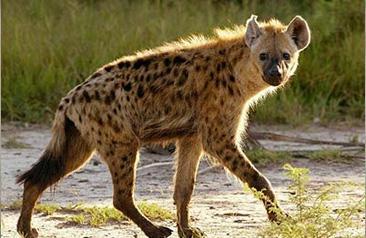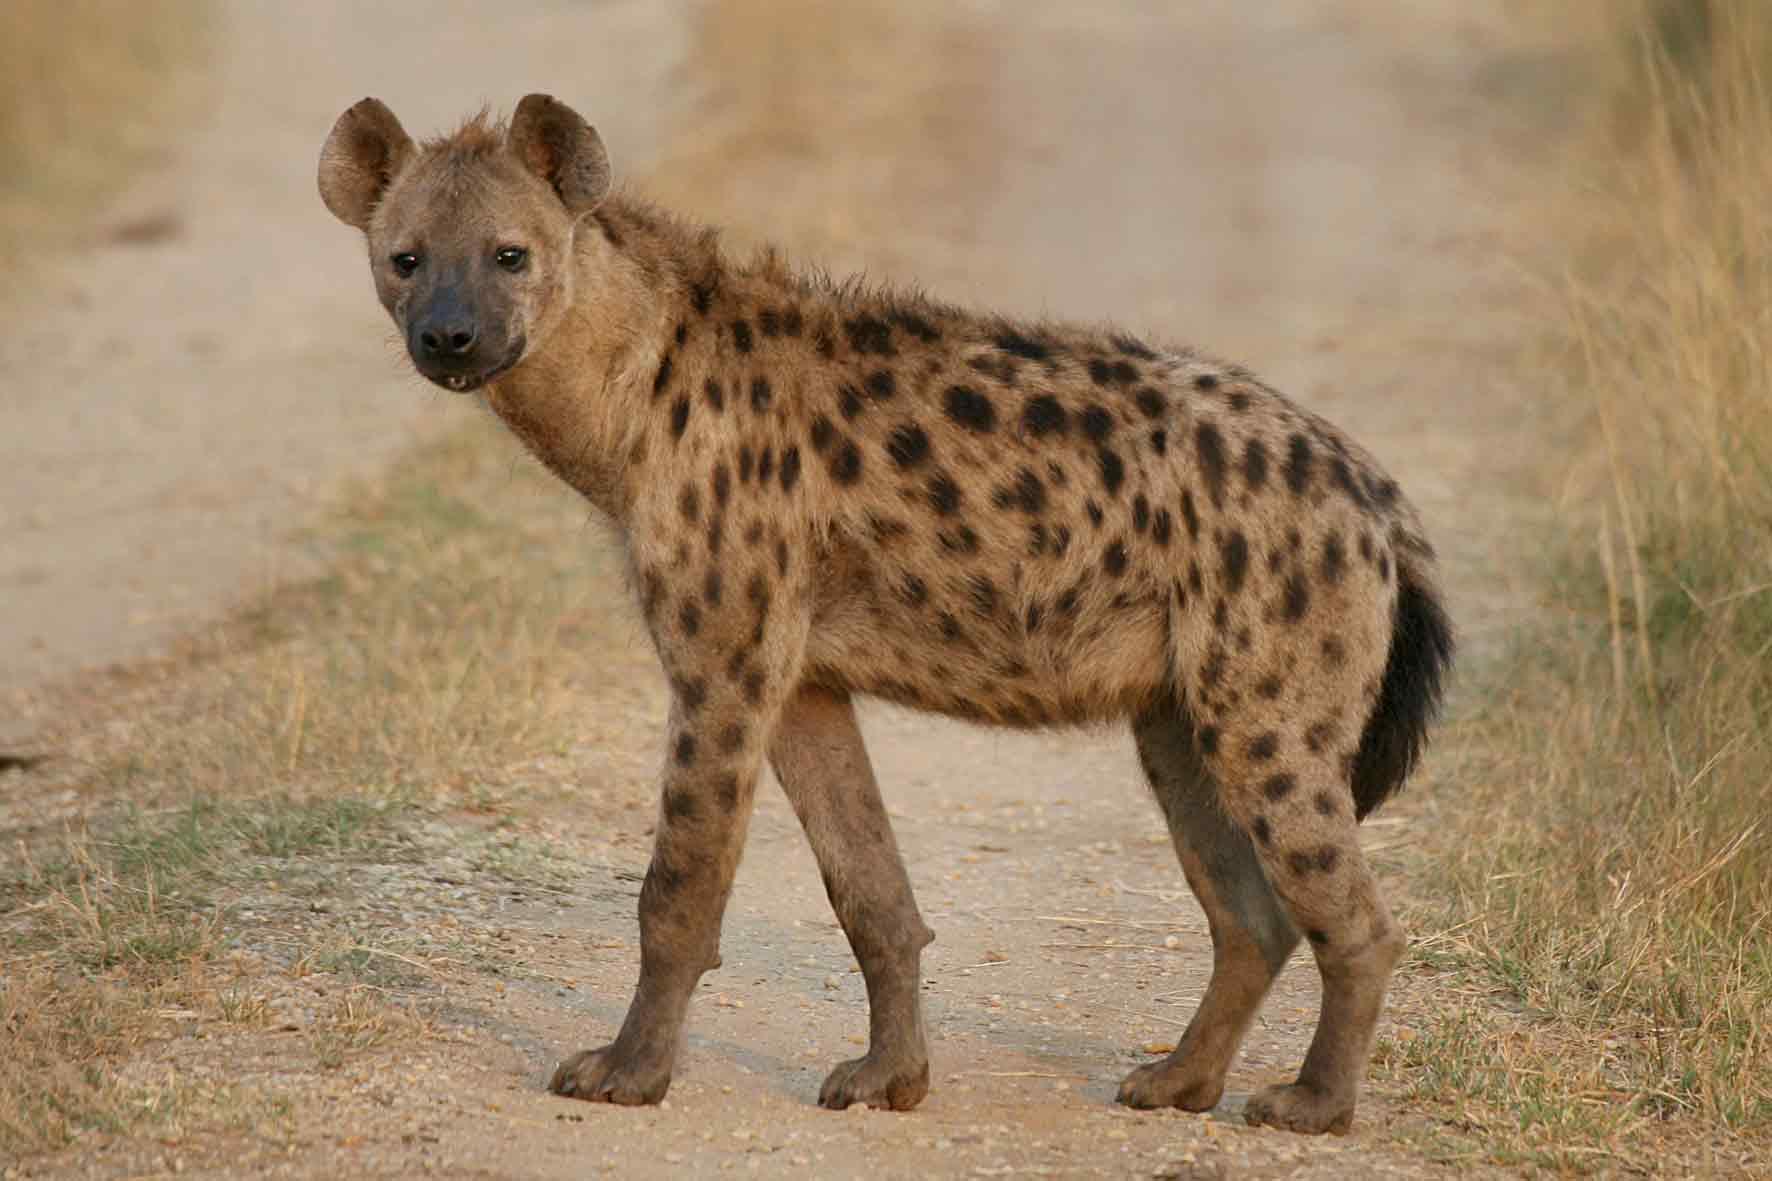The first image is the image on the left, the second image is the image on the right. For the images shown, is this caption "In one of the images, there is one hyena with its mouth open bearing its teeth" true? Answer yes or no. No. 